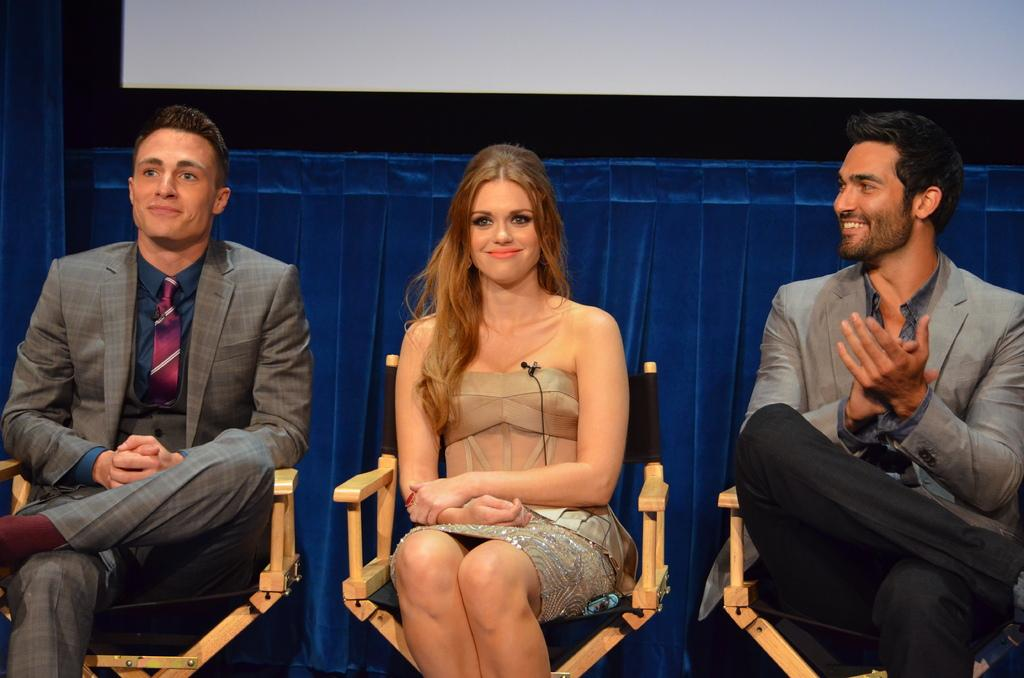What is the woman in the image doing? The woman is sitting in a chair in the image. Are there any other people in the image? Yes, there are two persons sitting on either side of the woman. What color is the cloth visible in the image? The cloth visible in the image is blue. How does the woman's idea affect the heat in the room? There is no information about the woman's idea or the heat in the room in the image, so it cannot be determined. 